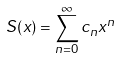Convert formula to latex. <formula><loc_0><loc_0><loc_500><loc_500>S ( x ) = \sum _ { n = 0 } ^ { \infty } c _ { n } x ^ { n }</formula> 